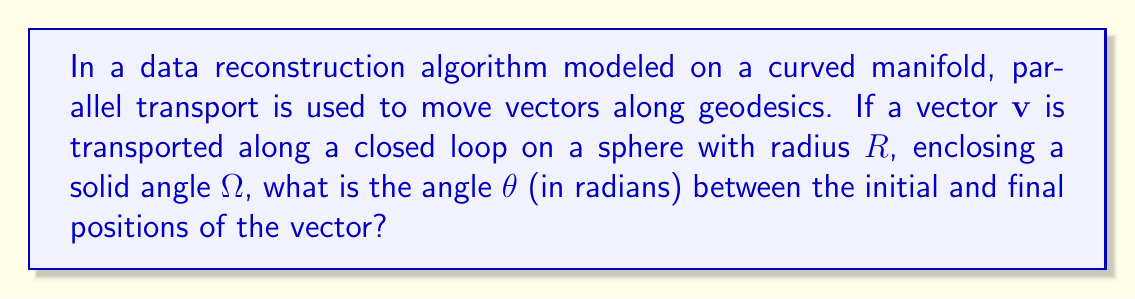Teach me how to tackle this problem. To solve this problem, we'll follow these steps:

1) In non-Euclidean geometry, parallel transport along a closed loop on a curved surface can result in a rotation of the transported vector. This effect is known as holonomy.

2) On a sphere, the holonomy angle $\theta$ is related to the solid angle $\Omega$ enclosed by the loop and the Gaussian curvature $K$ of the surface.

3) The relationship is given by the equation:

   $$\theta = \int\int K dA = \Omega K$$

   where $dA$ is an element of area on the surface.

4) For a sphere of radius $R$, the Gaussian curvature is constant and given by:

   $$K = \frac{1}{R^2}$$

5) Substituting this into our equation:

   $$\theta = \Omega \cdot \frac{1}{R^2}$$

6) The solid angle $\Omega$ is measured in steradians. On a sphere, it's related to the area $A$ of the enclosed region by:

   $$\Omega = \frac{A}{R^2}$$

7) Therefore, we can simplify our equation to:

   $$\theta = \frac{\Omega}{R^2} = \frac{A}{R^4}$$

This final equation gives us the angle of rotation after parallel transport around a closed loop on a sphere, in terms of the enclosed area and the sphere's radius.
Answer: $$\theta = \frac{\Omega}{R^2}$$ 